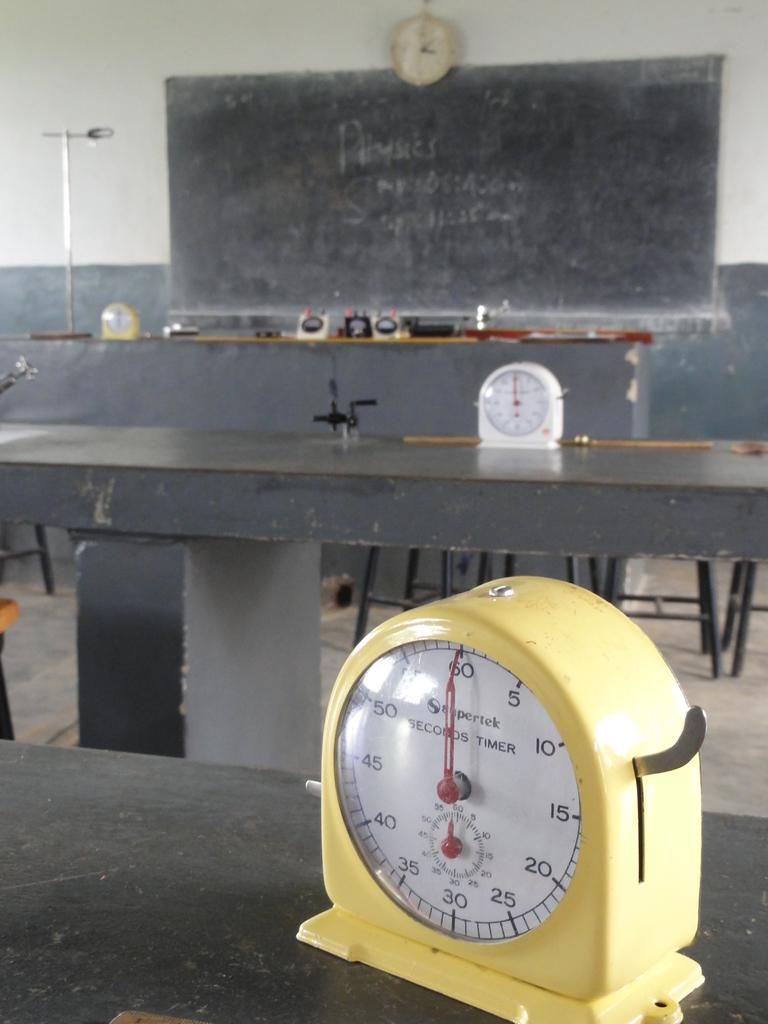<image>
Present a compact description of the photo's key features. On the tables sit some seconds timers and the dials are at the 60/0 mark. 